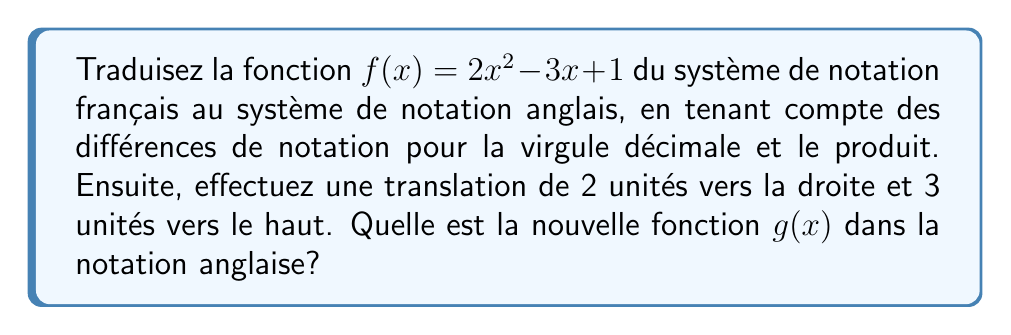Could you help me with this problem? 1. Traduction de la notation française à la notation anglaise:
   - En français, la virgule (,) est utilisée comme séparateur décimal, tandis qu'en anglais, c'est le point (.).
   - En français, le produit est souvent implicite (2x), tandis qu'en anglais, on utilise généralement un point (2·x).
   
   Donc, $f(x) = 2x^2 - 3x + 1$ devient $f(x) = 2\cdot x^2 - 3\cdot x + 1$

2. Translation de 2 unités vers la droite:
   - Remplacer chaque $x$ par $(x - 2)$
   $f(x-2) = 2\cdot (x-2)^2 - 3\cdot (x-2) + 1$

3. Translation de 3 unités vers le haut:
   - Ajouter 3 à la fonction
   $g(x) = 2\cdot (x-2)^2 - 3\cdot (x-2) + 1 + 3$

4. Simplification:
   $g(x) = 2\cdot (x-2)^2 - 3\cdot (x-2) + 4$
   $g(x) = 2\cdot (x^2 - 4x + 4) - 3x + 6 + 4$
   $g(x) = 2\cdot x^2 - 8\cdot x + 8 - 3\cdot x + 10$
   $g(x) = 2\cdot x^2 - 11\cdot x + 18$
Answer: $g(x) = 2\cdot x^2 - 11\cdot x + 18$ 